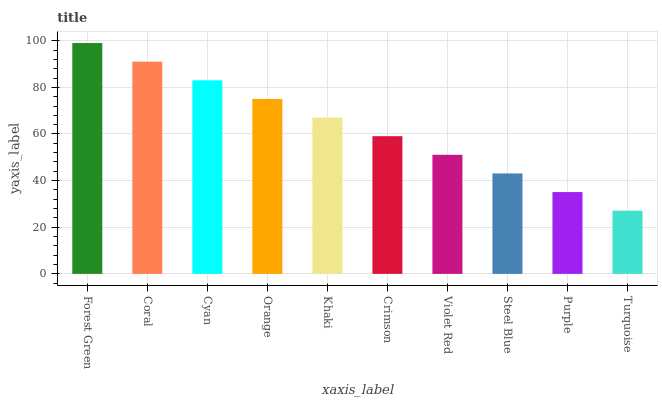Is Turquoise the minimum?
Answer yes or no. Yes. Is Forest Green the maximum?
Answer yes or no. Yes. Is Coral the minimum?
Answer yes or no. No. Is Coral the maximum?
Answer yes or no. No. Is Forest Green greater than Coral?
Answer yes or no. Yes. Is Coral less than Forest Green?
Answer yes or no. Yes. Is Coral greater than Forest Green?
Answer yes or no. No. Is Forest Green less than Coral?
Answer yes or no. No. Is Khaki the high median?
Answer yes or no. Yes. Is Crimson the low median?
Answer yes or no. Yes. Is Steel Blue the high median?
Answer yes or no. No. Is Cyan the low median?
Answer yes or no. No. 